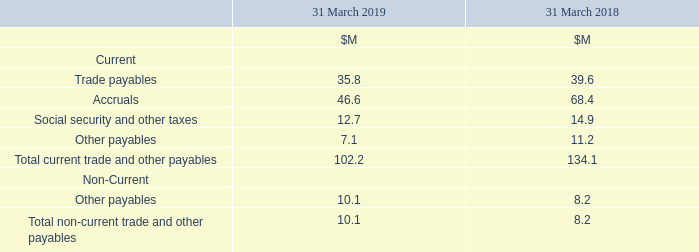22 Trade and Other Payables
Trade payables are non interest-bearing and are normally settled on 30-day terms or as otherwise agreed with suppliers.
What are the conditions for trade payables? Trade payables are non interest-bearing and are normally settled on 30-day terms or as otherwise agreed with suppliers. For which years are the trade and other payables calculated for? 2019, 2018. What are the components which make up the total Current trade and other payables? Trade payables, accruals, social security and other taxes, other payables. In which year was the amount of Total non-current trade and other payables larger? 10.1>8.2
Answer: 2019. What was the change in the Total non-current trade and other payables in 2019 from 2018?
Answer scale should be: million. 10.1-8.2
Answer: 1.9. What was the percentage change in the Total non-current trade and other payables in 2019 from 2018?
Answer scale should be: percent. (10.1-8.2)/8.2
Answer: 23.17. 